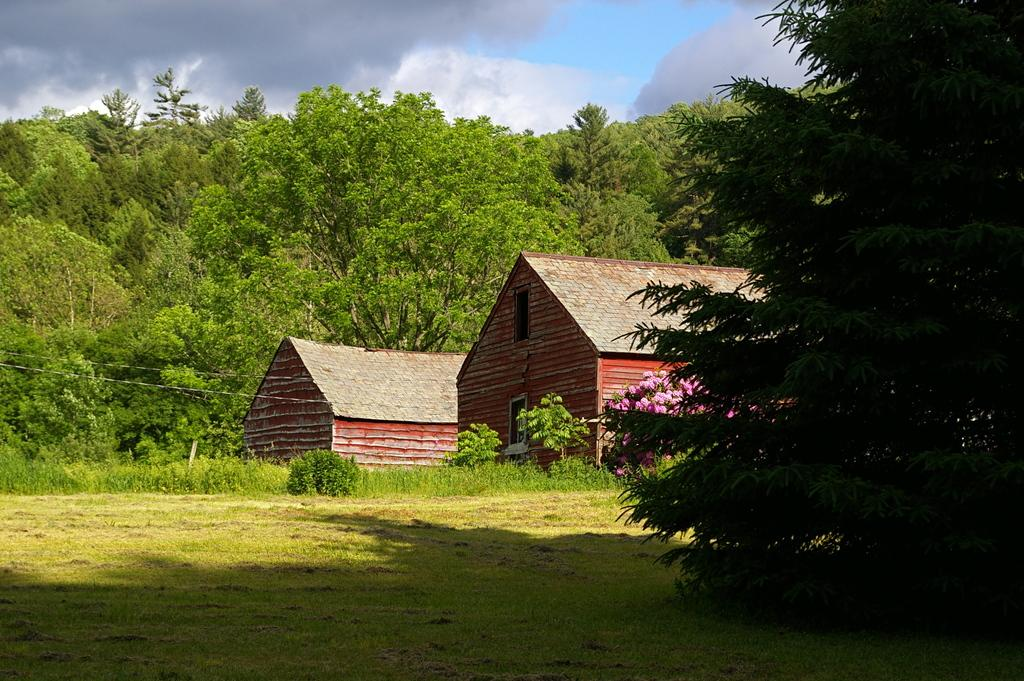What type of structures can be seen in the picture? There are houses in the picture. What other natural elements are present in the picture? There are trees in the picture. What can be seen in the background of the picture? The sky is visible in the background of the picture. How would you describe the sky in the picture? The sky appears to be clear in the picture. How many zebras can be seen crossing the road in the picture? There are no zebras or roads present in the picture; it features houses, trees, and a clear sky. 